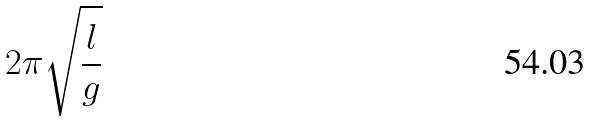Convert formula to latex. <formula><loc_0><loc_0><loc_500><loc_500>2 \pi \sqrt { \frac { l } { g } }</formula> 